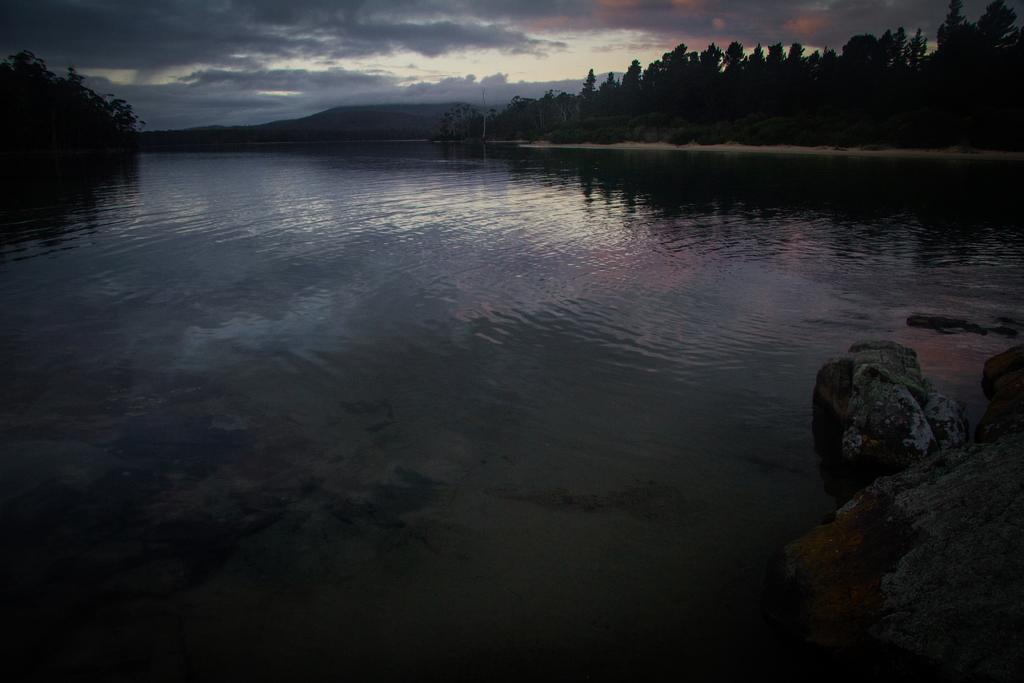What is the main feature of the image? There is a large water body in the image. What can be seen on the ground in the image? There are stones visible in the image. What type of vegetation is present in the background of the image? There is a group of trees in the background of the image. What other structures can be seen in the background of the image? There is a pole in the background of the image. What type of landscape is visible in the background of the image? There are hills visible in the background of the image. What is the weather condition in the image? The sky is visible in the background of the image, and it appears cloudy. What type of joke is being told by the trees in the image? There are no jokes being told in the image; the trees are not anthropomorphic. 